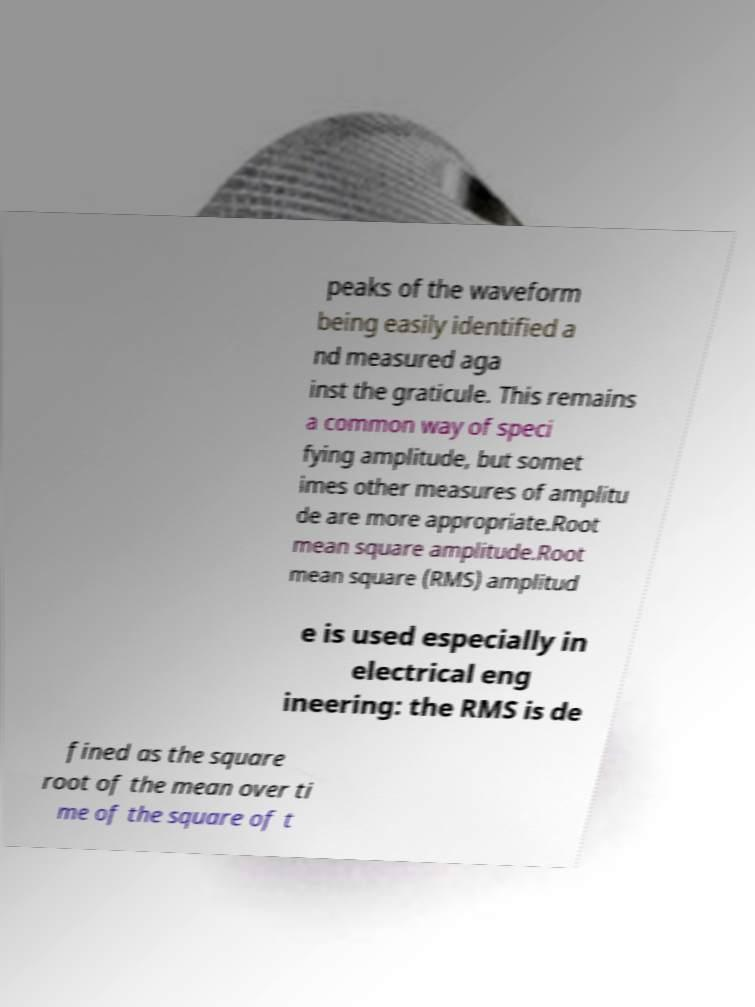There's text embedded in this image that I need extracted. Can you transcribe it verbatim? peaks of the waveform being easily identified a nd measured aga inst the graticule. This remains a common way of speci fying amplitude, but somet imes other measures of amplitu de are more appropriate.Root mean square amplitude.Root mean square (RMS) amplitud e is used especially in electrical eng ineering: the RMS is de fined as the square root of the mean over ti me of the square of t 